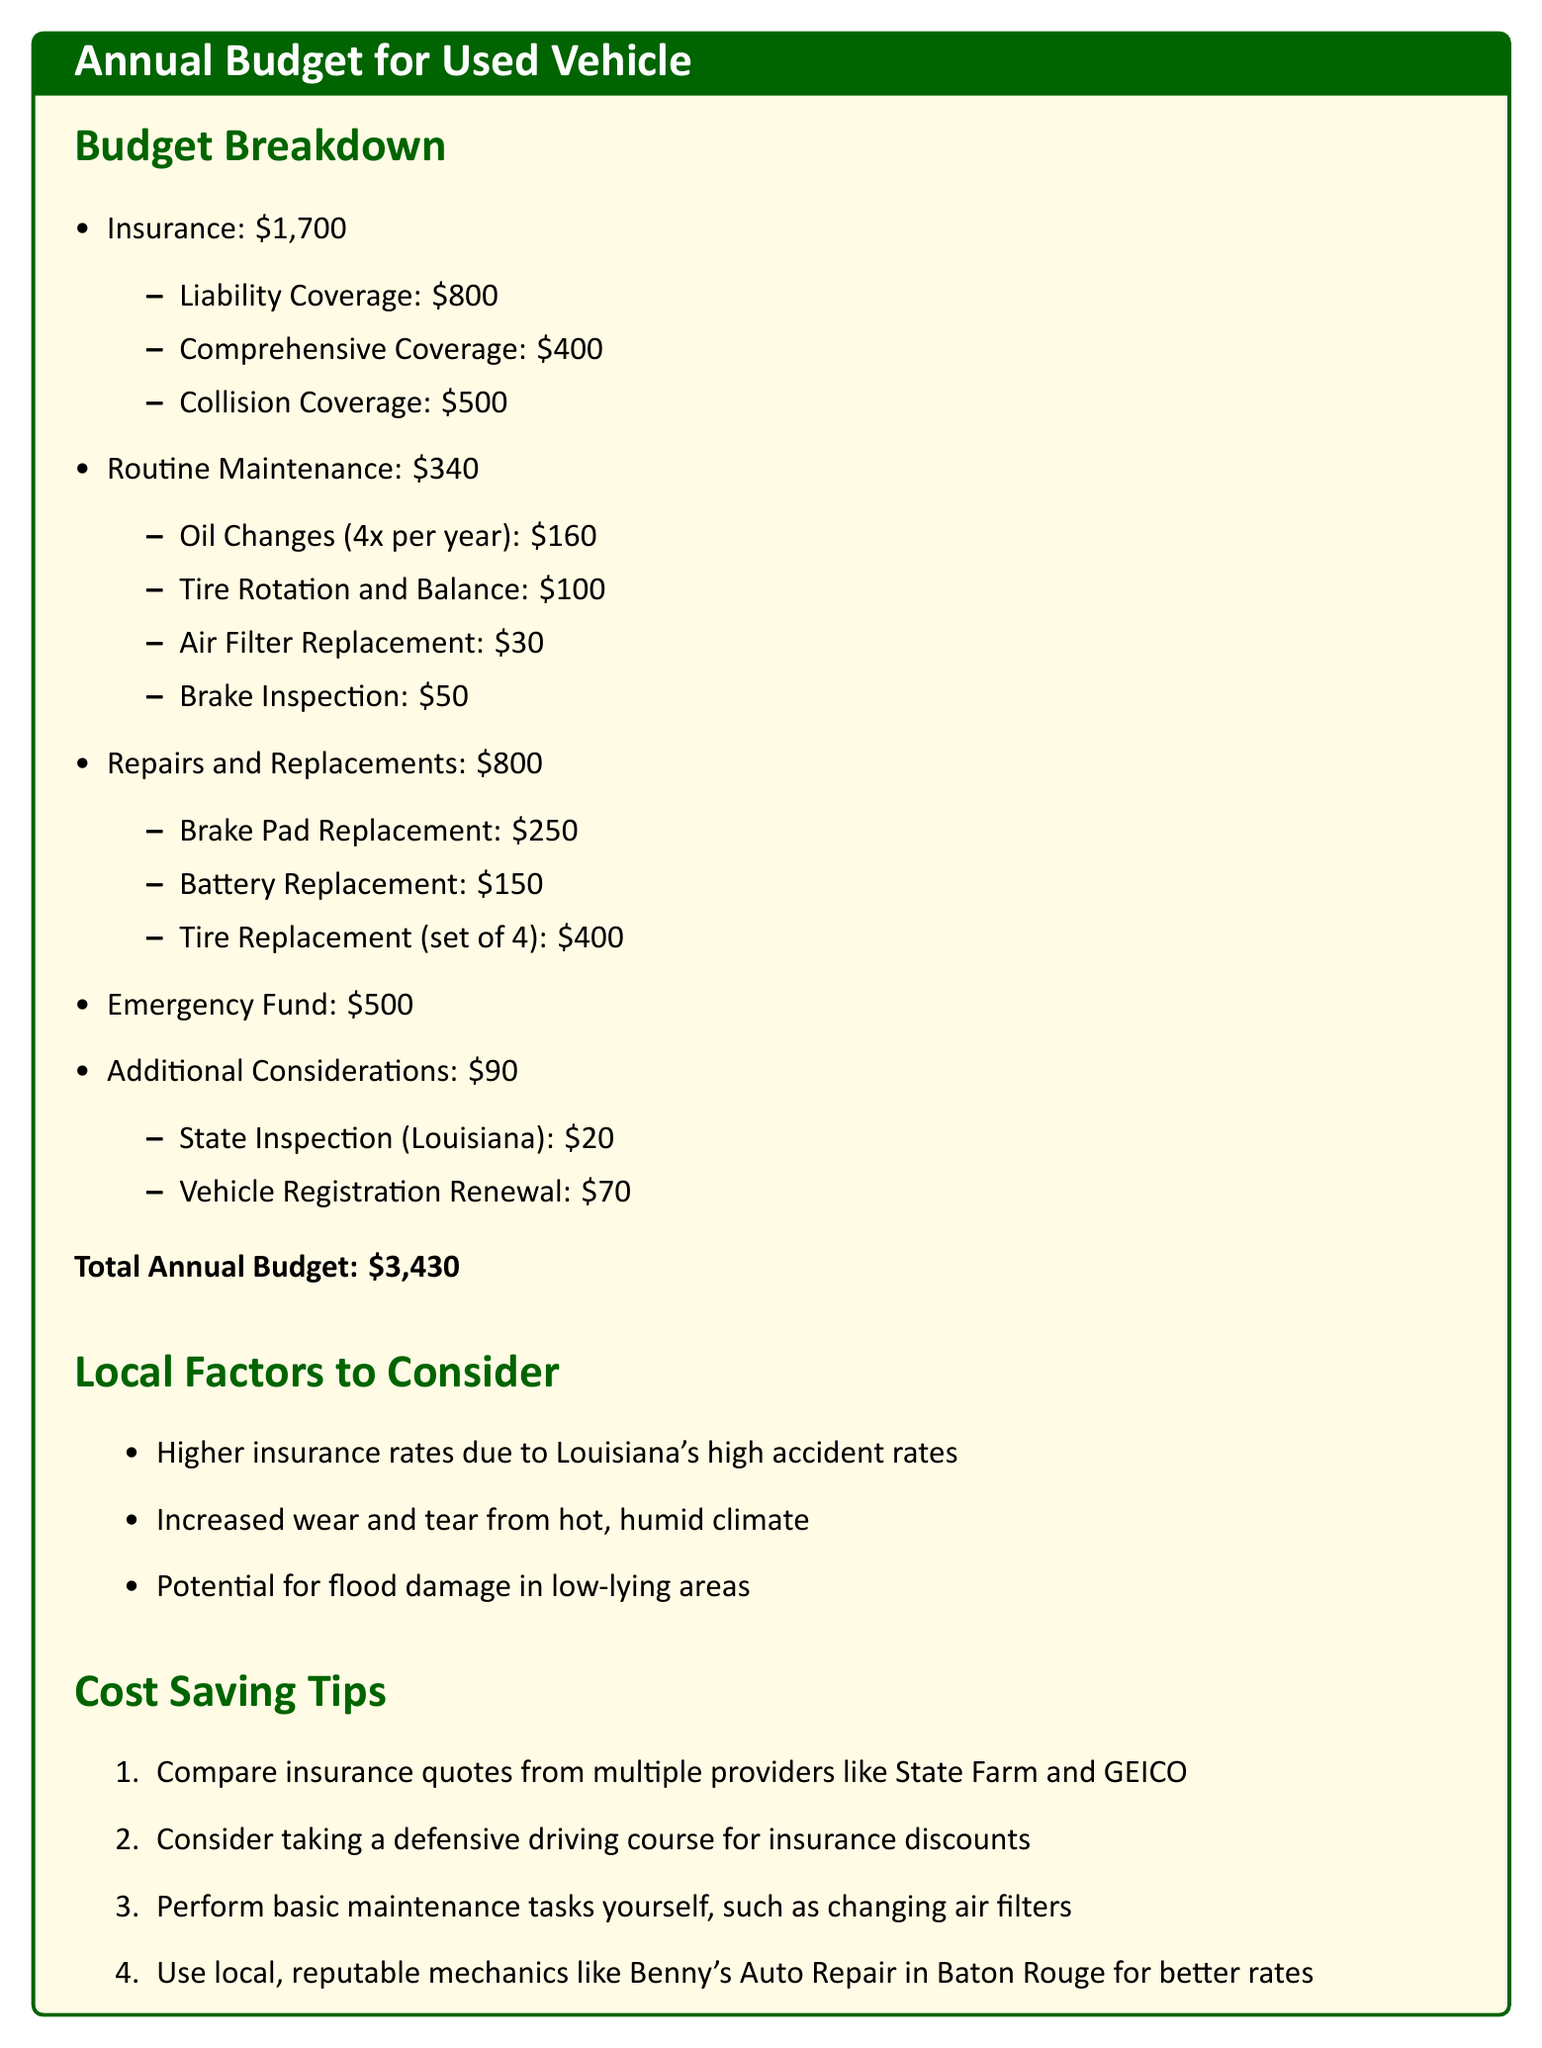What is the total annual budget for the used vehicle? The total annual budget is clearly stated at the end of the document as $3,430.
Answer: $3,430 How much is spent on insurance? The insurance cost is broken down in the budget, totaling $1,700.
Answer: $1,700 What is the cost of routine maintenance? The routine maintenance expenses are outlined in the budget as $340.
Answer: $340 How much is allocated for repairs and replacements? The budget lists repairs and replacements costs totaling $800.
Answer: $800 What is the cost of the state inspection in Louisiana? The document specifies that the cost of the state inspection is $20.
Answer: $20 Which coverage is the most expensive? The budget indicates that liability coverage is the most expensive at $800.
Answer: \$800 What factors are affecting insurance rates in Louisiana? The document mentions higher insurance rates due to Louisiana's high accident rates.
Answer: High accident rates What is one of the cost-saving tips provided? The document lists several tips, one being to compare insurance quotes from multiple providers.
Answer: Compare insurance quotes How many oil changes are included in the routine maintenance budget? The routine maintenance section states there are four oil changes per year.
Answer: 4 What is the emergency fund amount in the budget? The budget outlines an emergency fund of $500.
Answer: $500 